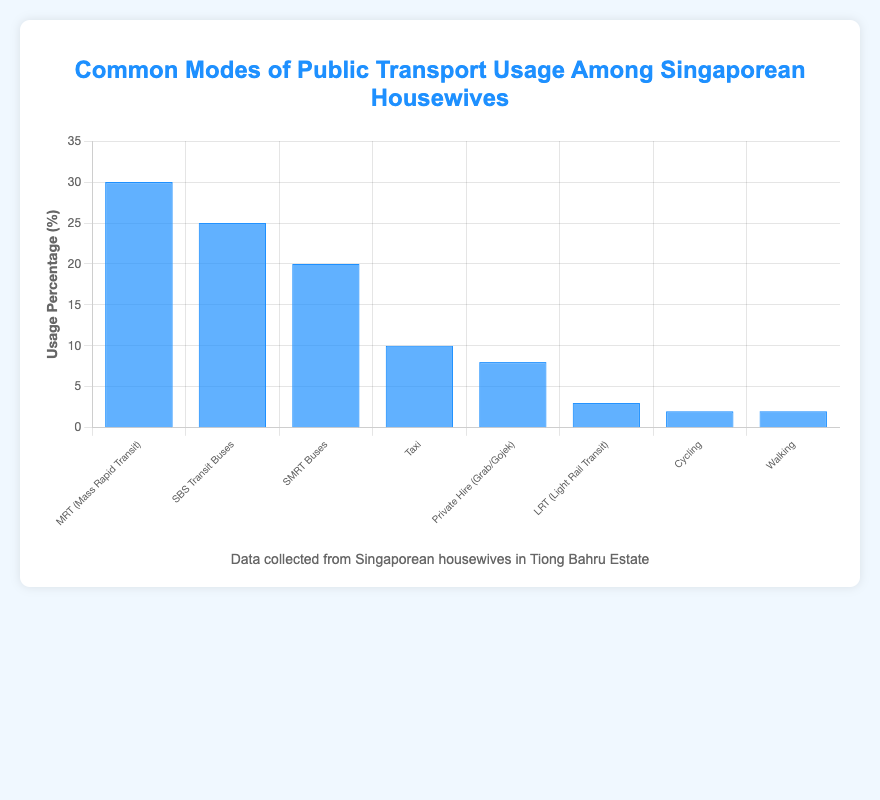What is the most common mode of public transport used by Singaporean housewives according to the figure? The highest blue bar represents the MRT (Mass Rapid Transit) with a 30% usage percentage. This indicates that the MRT is the most commonly used mode of transport among Singaporean housewives.
Answer: MRT (Mass Rapid Transit) Which mode of transport has the second-highest usage percentage? The second tallest blue bar corresponds to SBS Transit Buses with a 25% usage percentage. This indicates that SBS Transit Buses are the second most commonly used mode of transport among Singaporean housewives.
Answer: SBS Transit Buses How does the usage percentage of Taxis compare to Private Hire (Grab/Gojek)? Taxis have a usage percentage of 10%, while Private Hire (Grab/Gojek) has a usage percentage of 8%. This means that Taxis are used 2% more than Private Hire vehicles.
Answer: Taxis are used 2% more than Private Hire What is the total usage percentage for cycling and walking combined? The usage percentage for Cycling is 2%, and for Walking, it is also 2%. Adding them together, 2% + 2% = 4%.
Answer: 4% Which mode of transport has the lowest usage percentage, and what is that percentage? Both Cycling and Walking have the lowest usage percentages, each with 2%.
Answer: Cycling and Walking with 2% Is the usage percentage of MRT higher than the combined usage percentage of Taxis and Private Hire? MRT usage is 30%. The combined usage of Taxis (10%) and Private Hire (8%) is 10% + 8% = 18%. Since 30% is greater than 18%, MRT usage is higher.
Answer: Yes, MRT usage is higher What is the combined usage percentage for MRT, SBS Transit Buses, and SMRT Buses? The usage percentages are MRT (30%), SBS Transit Buses (25%), and SMRT Buses (20%). Adding them together, 30% + 25% + 20% = 75%.
Answer: 75% Which mode of transport has a usage percentage closest to the average usage percentage of all modes? The average usage percentage is calculated by summing all percentages (30 + 25 + 20 + 10 + 8 + 3 + 2 + 2 = 100) and dividing by the number of modes (8). So, 100/8 = 12.5%. The usage percentage closest to 12.5% is 10% (Taxi).
Answer: Taxi with 10% Among the modes with a usage percentage below 5%, which has a higher percentage? The modes below 5% are LRT (3%), Cycling (2%), and Walking (2%). The highest among these is LRT at 3%.
Answer: LRT with 3% How much more is the MRT used compared to the LRT? MRT usage is 30%, and LRT usage is 3%. The difference is 30% - 3% = 27%.
Answer: 27% more 